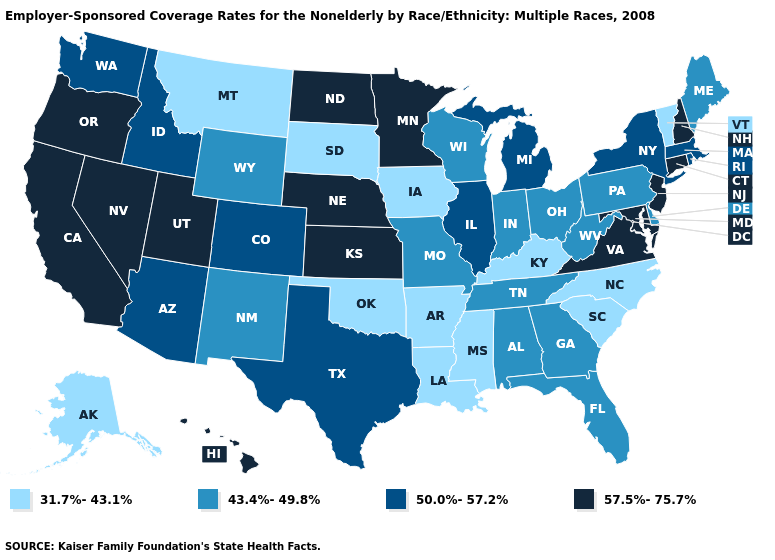Is the legend a continuous bar?
Write a very short answer. No. Name the states that have a value in the range 43.4%-49.8%?
Answer briefly. Alabama, Delaware, Florida, Georgia, Indiana, Maine, Missouri, New Mexico, Ohio, Pennsylvania, Tennessee, West Virginia, Wisconsin, Wyoming. Does Rhode Island have the highest value in the Northeast?
Be succinct. No. Among the states that border Wyoming , does Idaho have the highest value?
Be succinct. No. Among the states that border California , does Arizona have the lowest value?
Be succinct. Yes. Which states hav the highest value in the MidWest?
Keep it brief. Kansas, Minnesota, Nebraska, North Dakota. Among the states that border Delaware , which have the lowest value?
Short answer required. Pennsylvania. What is the value of Maryland?
Be succinct. 57.5%-75.7%. Name the states that have a value in the range 50.0%-57.2%?
Write a very short answer. Arizona, Colorado, Idaho, Illinois, Massachusetts, Michigan, New York, Rhode Island, Texas, Washington. What is the value of Utah?
Give a very brief answer. 57.5%-75.7%. What is the highest value in the Northeast ?
Give a very brief answer. 57.5%-75.7%. What is the value of Vermont?
Keep it brief. 31.7%-43.1%. What is the value of Wyoming?
Be succinct. 43.4%-49.8%. Does the first symbol in the legend represent the smallest category?
Concise answer only. Yes. Does West Virginia have the lowest value in the USA?
Be succinct. No. 